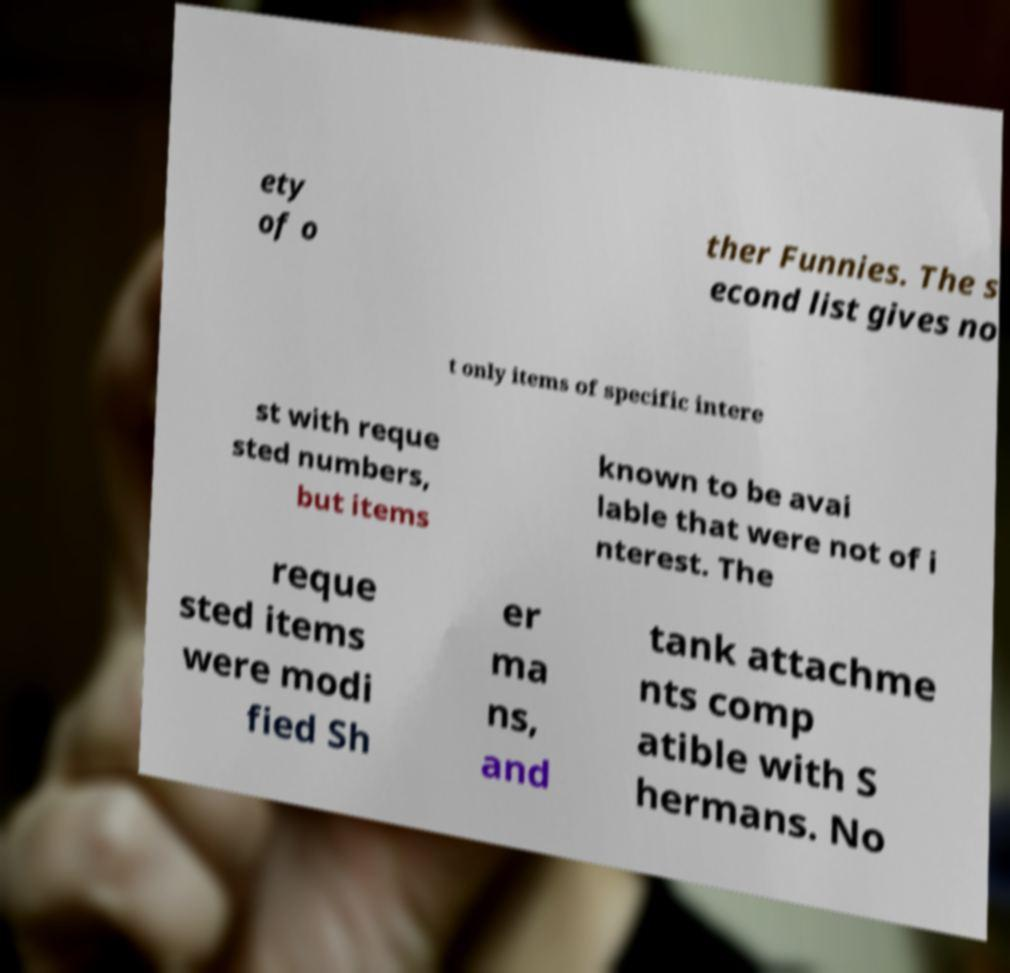I need the written content from this picture converted into text. Can you do that? ety of o ther Funnies. The s econd list gives no t only items of specific intere st with reque sted numbers, but items known to be avai lable that were not of i nterest. The reque sted items were modi fied Sh er ma ns, and tank attachme nts comp atible with S hermans. No 